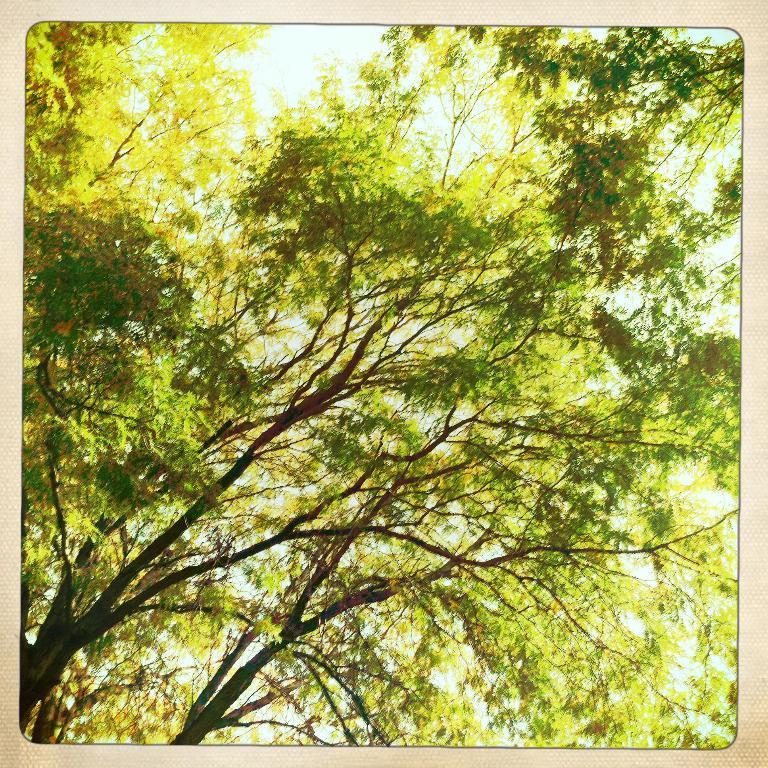In one or two sentences, can you explain what this image depicts? In this image there is one photo frame and in that photo frame there are some trees, and in the background there is sky. 